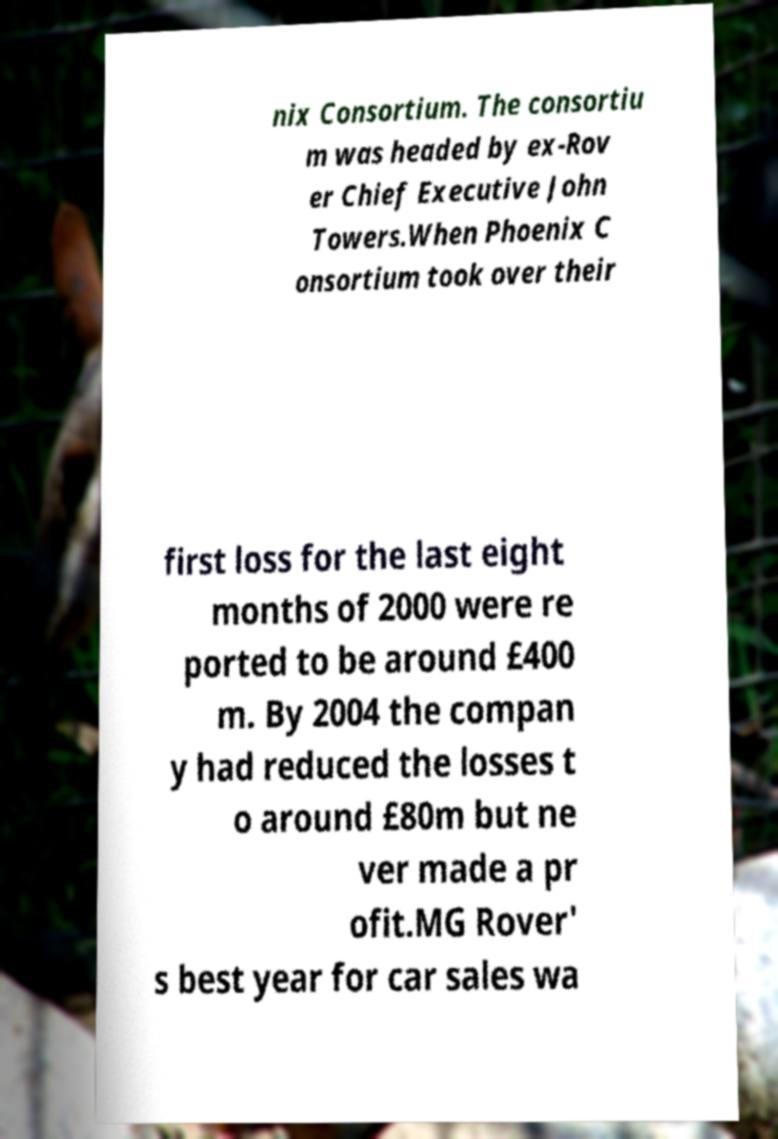What messages or text are displayed in this image? I need them in a readable, typed format. nix Consortium. The consortiu m was headed by ex-Rov er Chief Executive John Towers.When Phoenix C onsortium took over their first loss for the last eight months of 2000 were re ported to be around £400 m. By 2004 the compan y had reduced the losses t o around £80m but ne ver made a pr ofit.MG Rover' s best year for car sales wa 